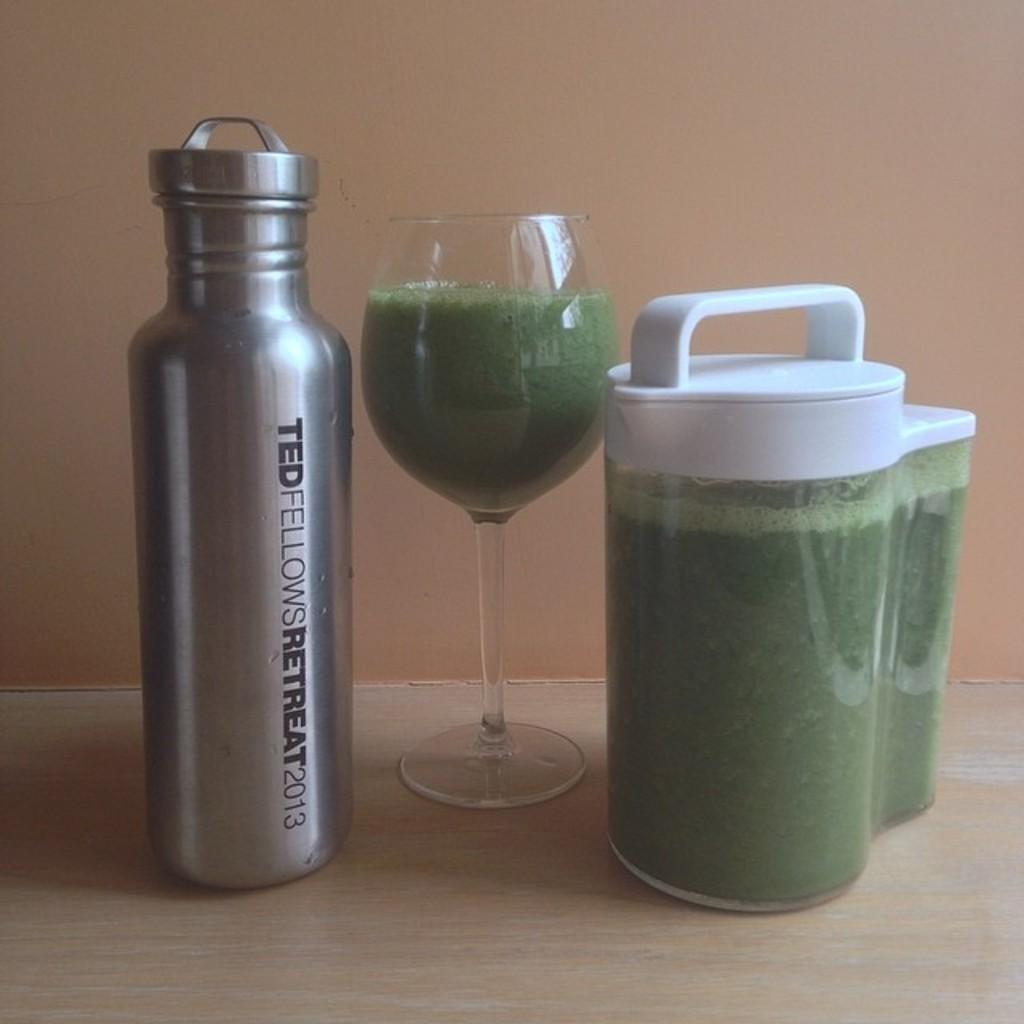Provide a one-sentence caption for the provided image. A metal bottle from the Ted Fellows Retreat in 2013 sits next to a green drink. 